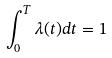<formula> <loc_0><loc_0><loc_500><loc_500>\int _ { 0 } ^ { T } \lambda ( t ) d t = 1</formula> 